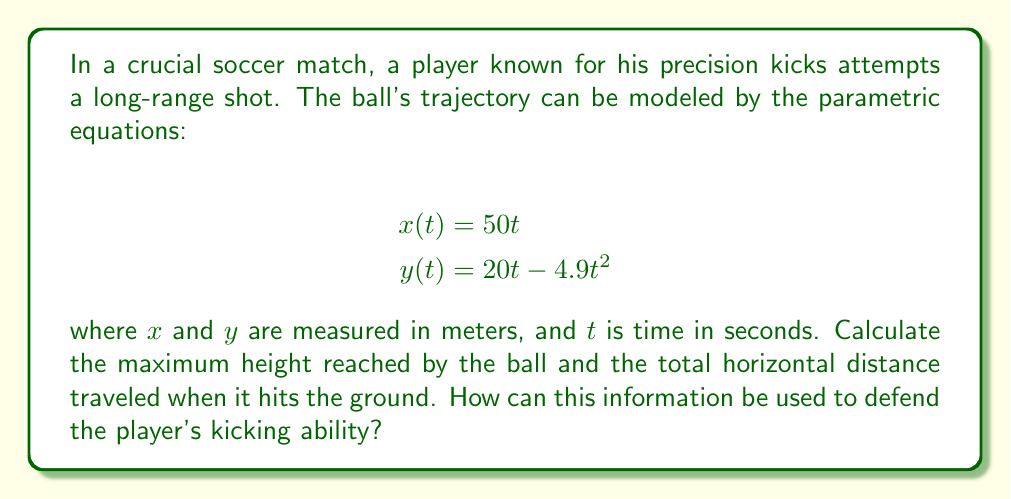Could you help me with this problem? 1. To find the maximum height, we need to determine when $\frac{dy}{dt} = 0$:

   $$\frac{dy}{dt} = 20 - 9.8t$$
   
   Set this equal to zero and solve for $t$:
   
   $$20 - 9.8t = 0$$
   $$t = \frac{20}{9.8} \approx 2.04\text{ seconds}$$

2. Plug this time back into $y(t)$ to find the maximum height:

   $$y(2.04) = 20(2.04) - 4.9(2.04)^2 \approx 20.41\text{ meters}$$

3. To find when the ball hits the ground, set $y(t) = 0$ and solve for $t$:

   $$20t - 4.9t^2 = 0$$
   $$t(20 - 4.9t) = 0$$
   $$t = 0\text{ or }t = \frac{20}{4.9} \approx 4.08\text{ seconds}$$

   We use the non-zero solution as it represents when the ball lands.

4. To find the horizontal distance, plug $t = 4.08$ into $x(t)$:

   $$x(4.08) = 50(4.08) \approx 204\text{ meters}$$

This analysis shows that the player's kick reached a impressive maximum height of about 20.41 meters and traveled a horizontal distance of approximately 204 meters. These statistics demonstrate the player's exceptional kicking power and accuracy, supporting the argument that their performance should be praised rather than criticized.
Answer: Maximum height: 20.41 m; Horizontal distance: 204 m 